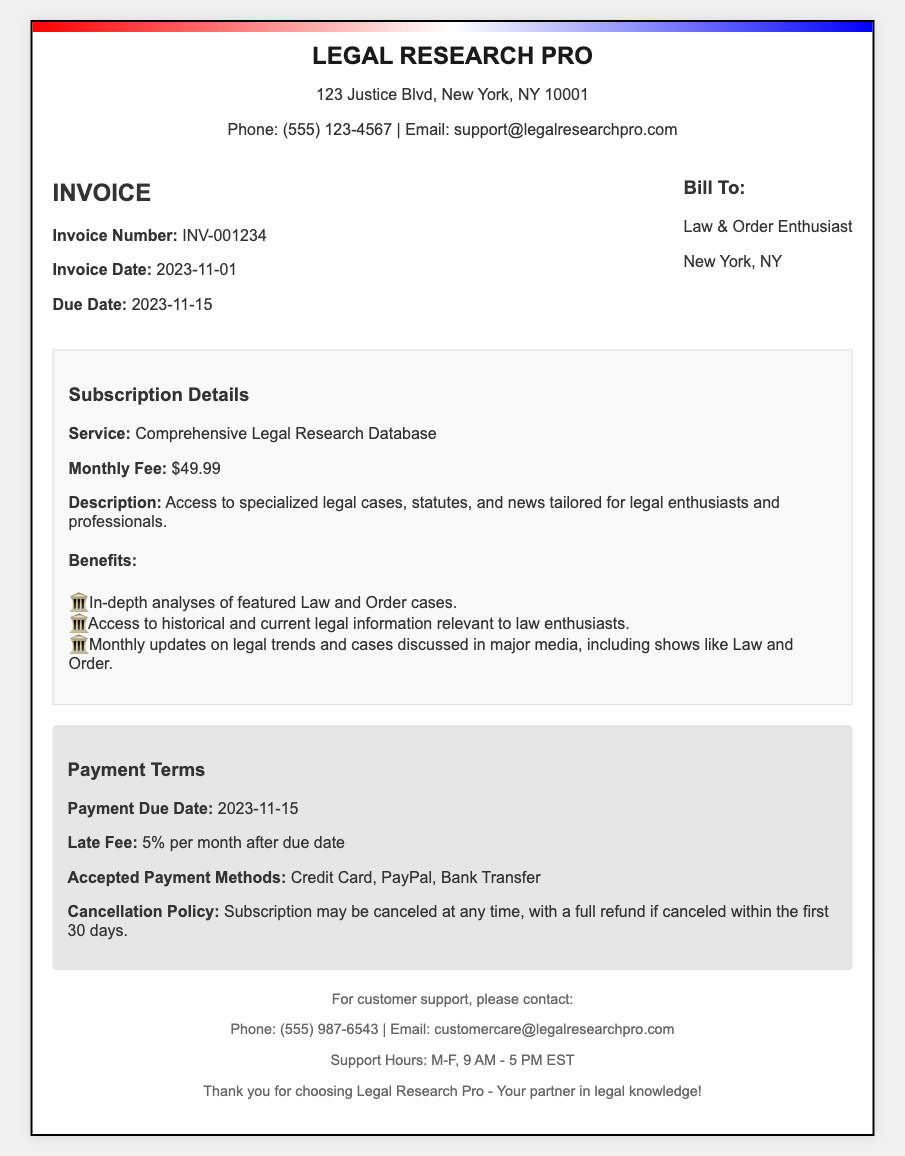What is the invoice number? The invoice number is a unique identifier for this specific transaction, found in the header section of the invoice.
Answer: INV-001234 What is the monthly fee for the service? The monthly fee is specified in the subscription details section, indicating how much will be charged each month.
Answer: $49.99 What is the due date for payment? The due date is a critical piece of information stating when the payment must be made, located under the invoice details.
Answer: 2023-11-15 What is the late fee percentage? The late fee percentage outlines the extra charge for late payments, mentioned in the payment terms section.
Answer: 5% What method of payment is accepted? The accepted payment methods inform clients how they can pay, found in the payment terms section.
Answer: Credit Card, PayPal, Bank Transfer What are the benefits of the subscription? This question explores the advantages mentioned in the document that come with the subscription to the legal research service.
Answer: In-depth analyses of featured Law and Order cases, Access to historical and current legal information relevant to law enthusiasts, Monthly updates on legal trends and cases discussed in major media, including shows like Law and Order What is the cancellation policy? The cancellation policy outlines the terms under which a subscriber can terminate their subscription, as specified in the payment terms.
Answer: Subscription may be canceled at any time, with a full refund if canceled within the first 30 days What is the address of the service provider? The address provides important contact information for the service provider, found in the header.
Answer: 123 Justice Blvd, New York, NY 10001 